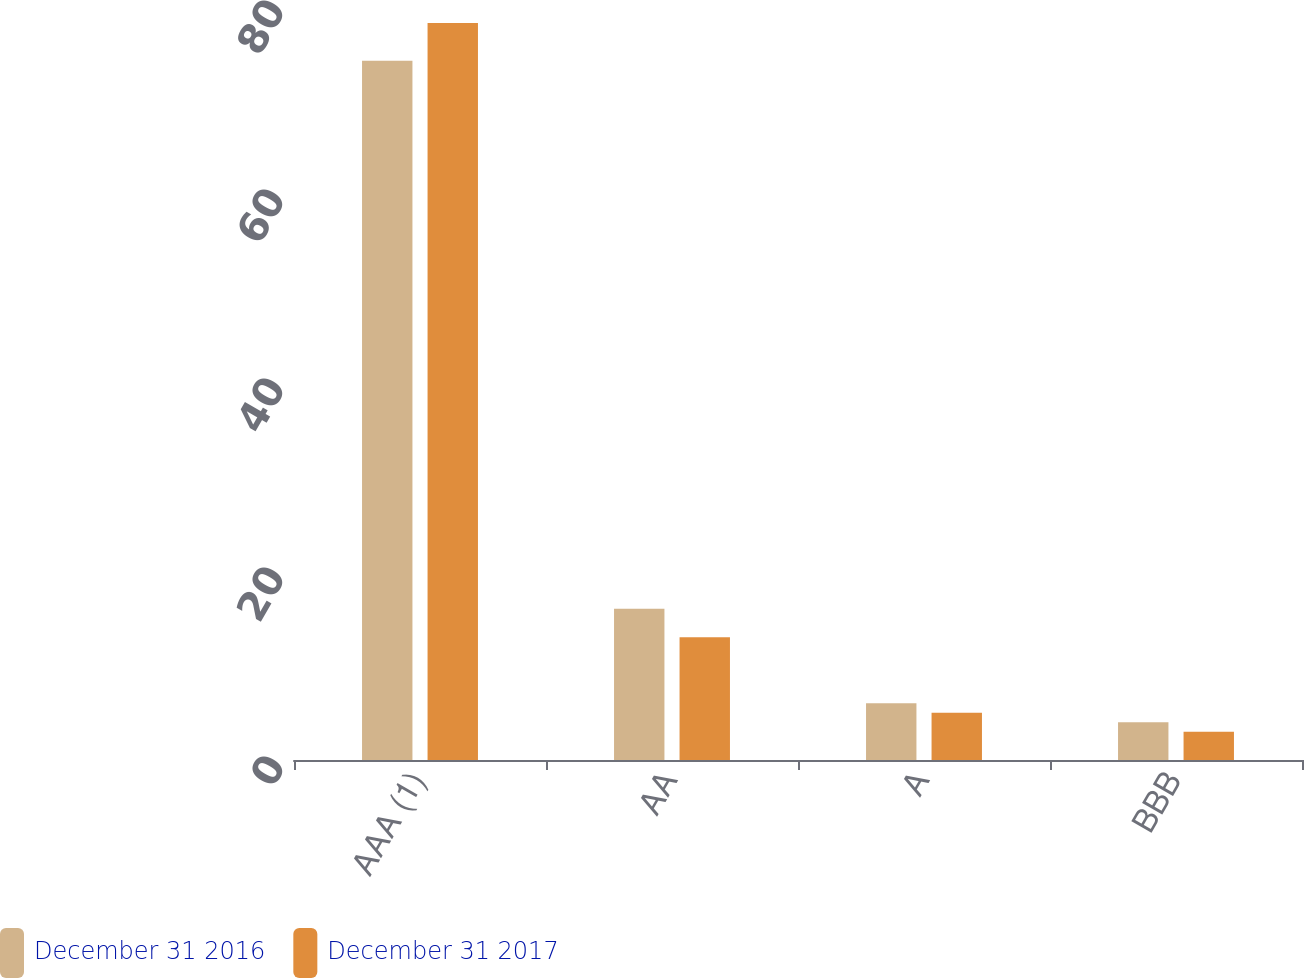<chart> <loc_0><loc_0><loc_500><loc_500><stacked_bar_chart><ecel><fcel>AAA (1)<fcel>AA<fcel>A<fcel>BBB<nl><fcel>December 31 2016<fcel>74<fcel>16<fcel>6<fcel>4<nl><fcel>December 31 2017<fcel>78<fcel>13<fcel>5<fcel>3<nl></chart> 